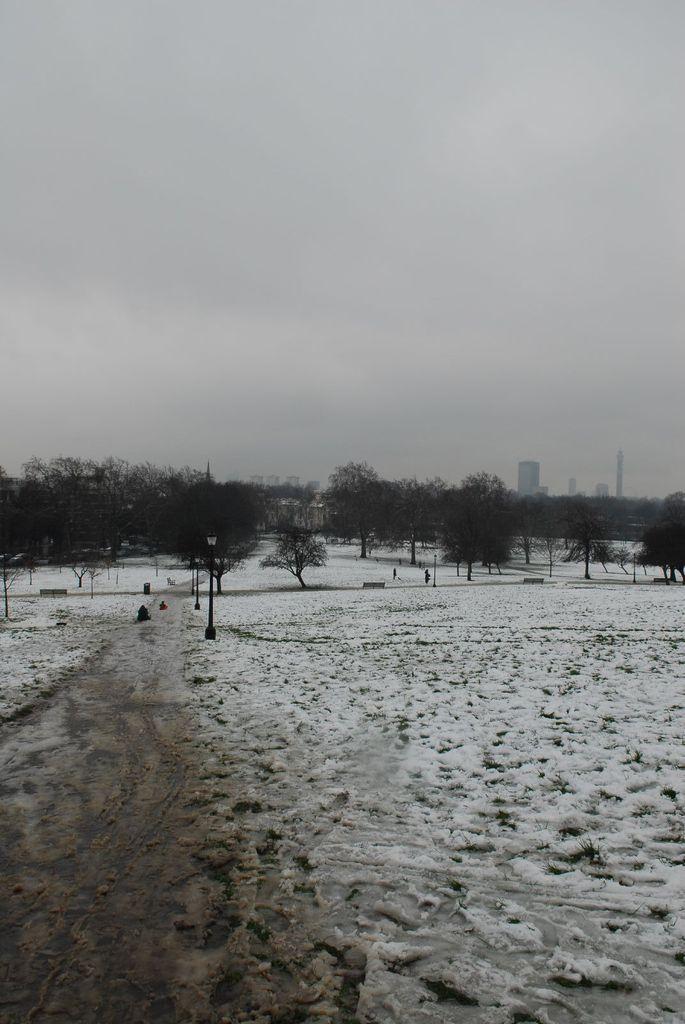Can you describe this image briefly? This image consists of trees in the middle. There are buildings in the middle. There is ice in this image. There is sky at the top. 